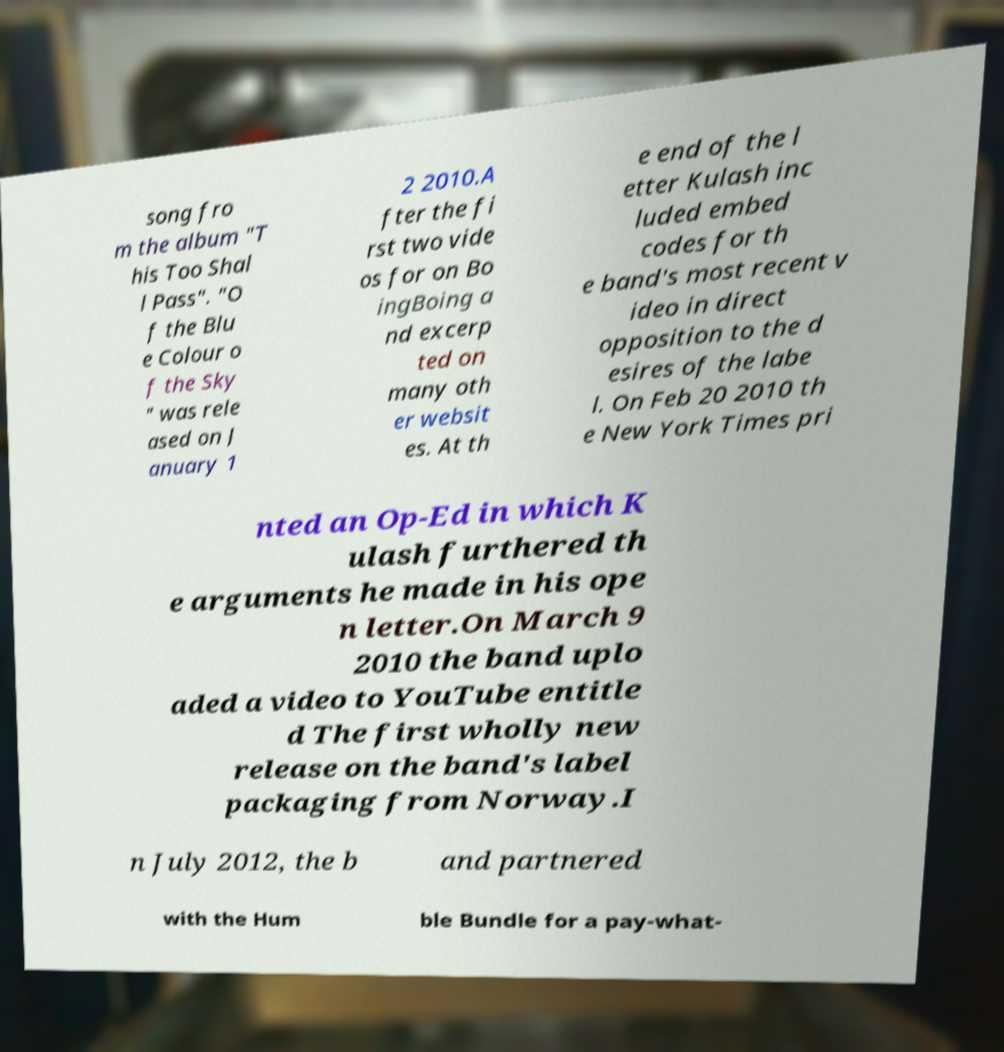Could you assist in decoding the text presented in this image and type it out clearly? song fro m the album "T his Too Shal l Pass". "O f the Blu e Colour o f the Sky " was rele ased on J anuary 1 2 2010.A fter the fi rst two vide os for on Bo ingBoing a nd excerp ted on many oth er websit es. At th e end of the l etter Kulash inc luded embed codes for th e band's most recent v ideo in direct opposition to the d esires of the labe l. On Feb 20 2010 th e New York Times pri nted an Op-Ed in which K ulash furthered th e arguments he made in his ope n letter.On March 9 2010 the band uplo aded a video to YouTube entitle d The first wholly new release on the band's label packaging from Norway.I n July 2012, the b and partnered with the Hum ble Bundle for a pay-what- 